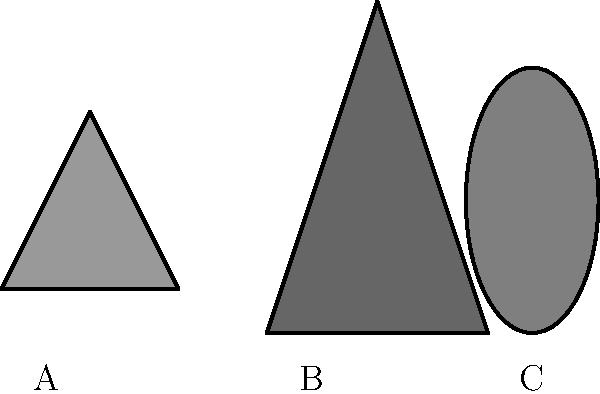Identify the Appalachian cryptid represented by silhouette B in the image above. To identify the cryptid represented by silhouette B, let's analyze each silhouette:

1. Silhouette A: This shape has wings and a small head, characteristic of the Mothman, a creature said to haunt Point Pleasant, West Virginia.

2. Silhouette B: This figure has a distinctly humanoid shape with a large, bulky body and a somewhat pointed head. The proportions and posture are consistent with descriptions of Bigfoot, also known as Sasquatch in other regions.

3. Silhouette C: This oval shape with a pointed top resembles the Flatwoods Monster, reported in Braxton County, West Virginia, often described as having a spade-shaped head.

Given the humanoid shape and the context of Appalachian cryptids, silhouette B most closely matches the descriptions and popular depictions of Bigfoot.
Answer: Bigfoot 